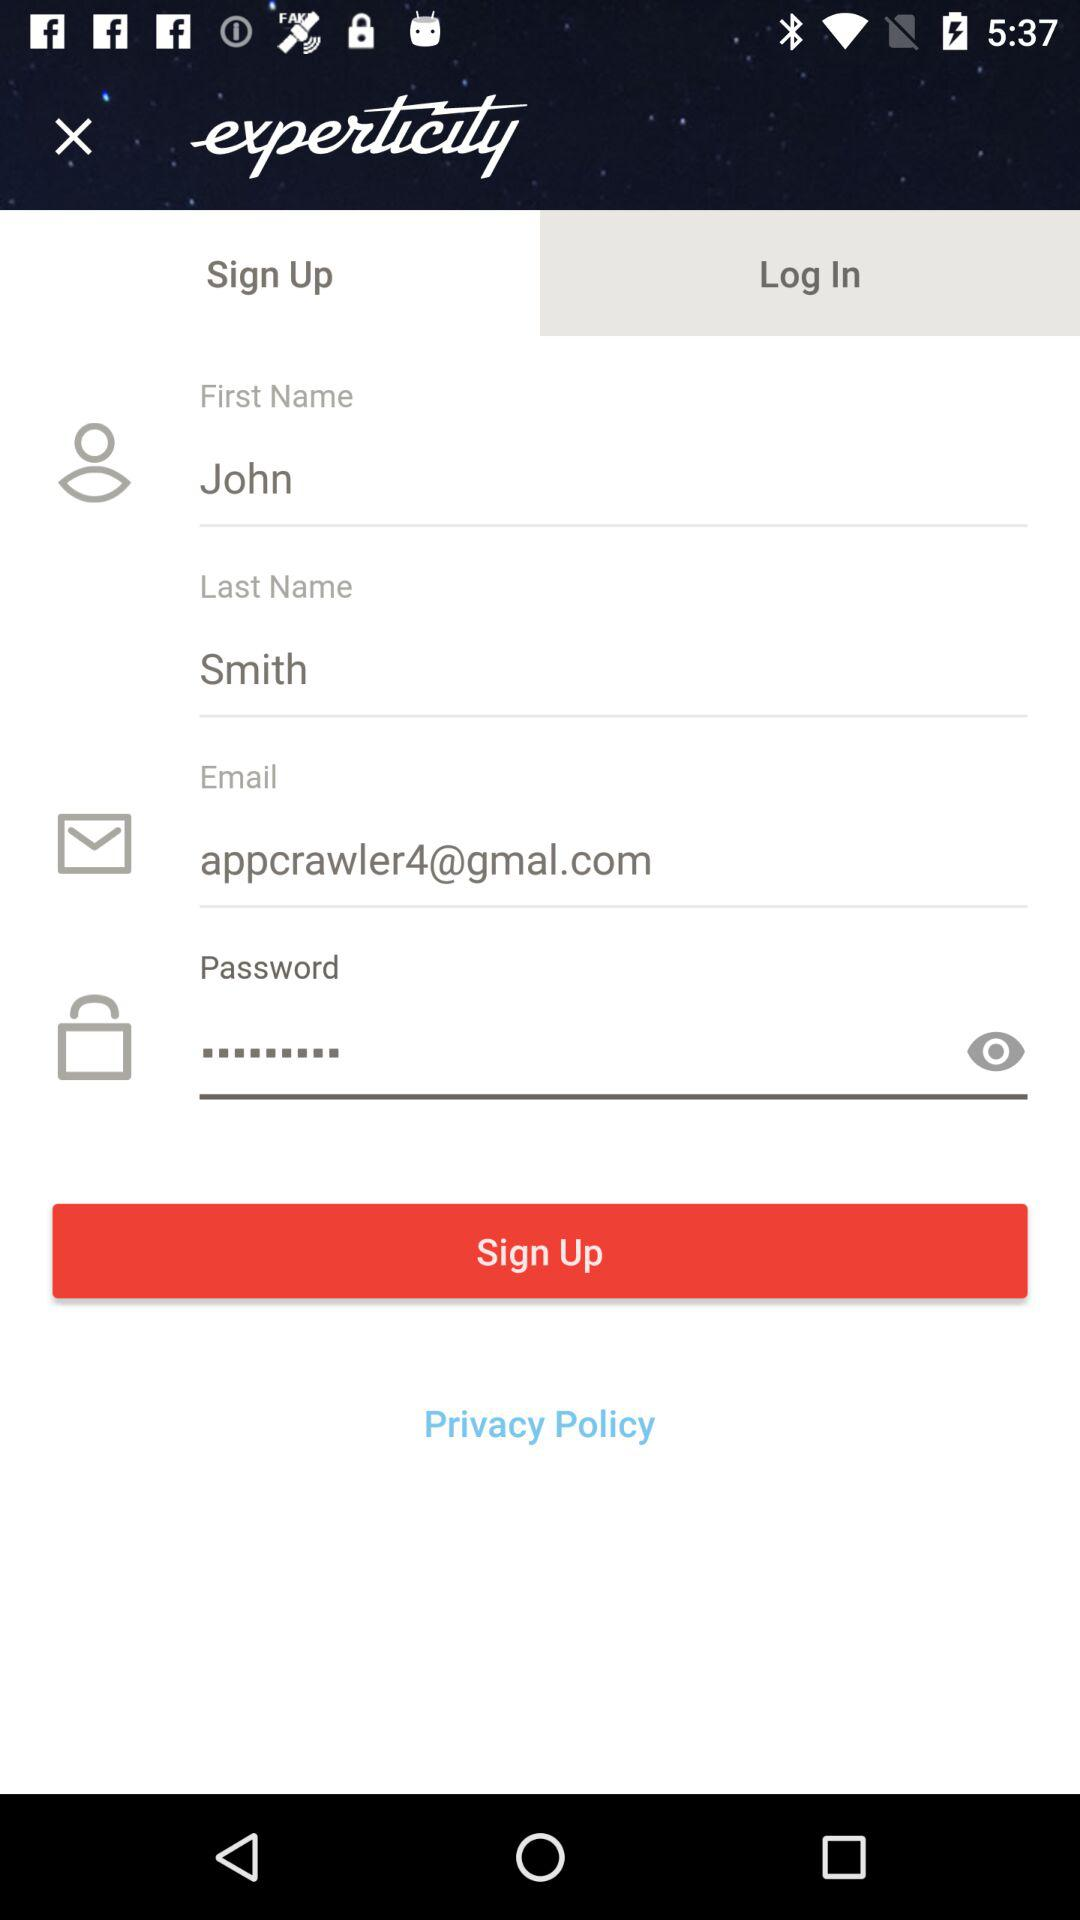What is the email address? The email address is appcrawler4@gmal.com. 